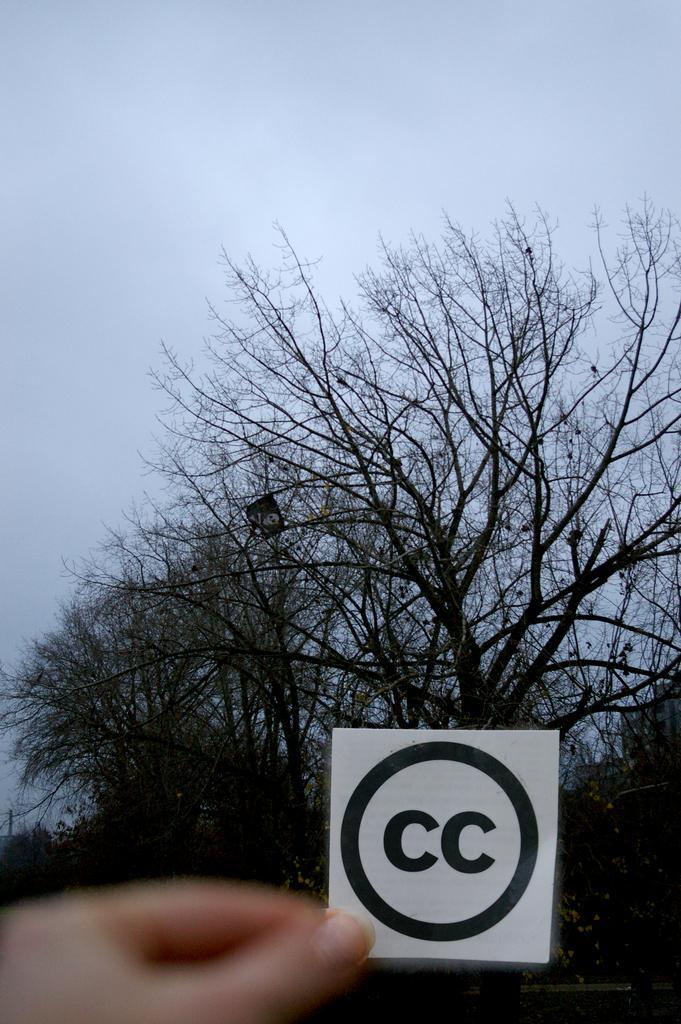Could you give a brief overview of what you see in this image? In the image there is a person holding a sign sticker in the front and behind there are trees and above its sky. 